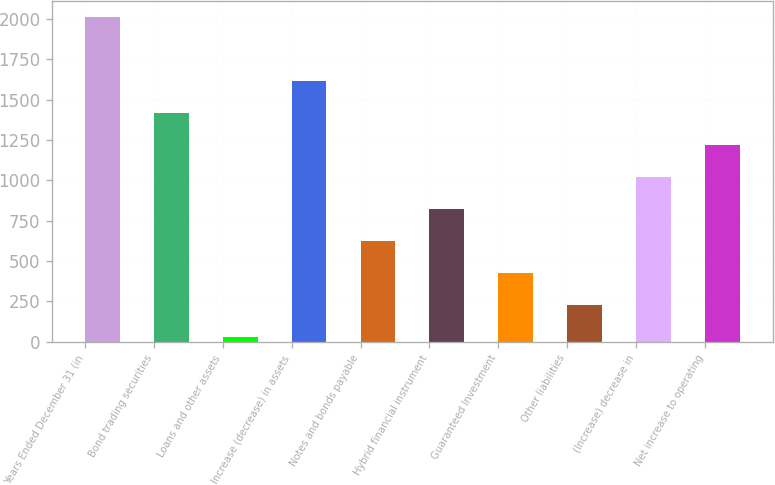<chart> <loc_0><loc_0><loc_500><loc_500><bar_chart><fcel>Years Ended December 31 (in<fcel>Bond trading securities<fcel>Loans and other assets<fcel>Increase (decrease) in assets<fcel>Notes and bonds payable<fcel>Hybrid financial instrument<fcel>Guaranteed Investment<fcel>Other liabilities<fcel>(Increase) decrease in<fcel>Net increase to operating<nl><fcel>2012<fcel>1417.1<fcel>29<fcel>1615.4<fcel>623.9<fcel>822.2<fcel>425.6<fcel>227.3<fcel>1020.5<fcel>1218.8<nl></chart> 